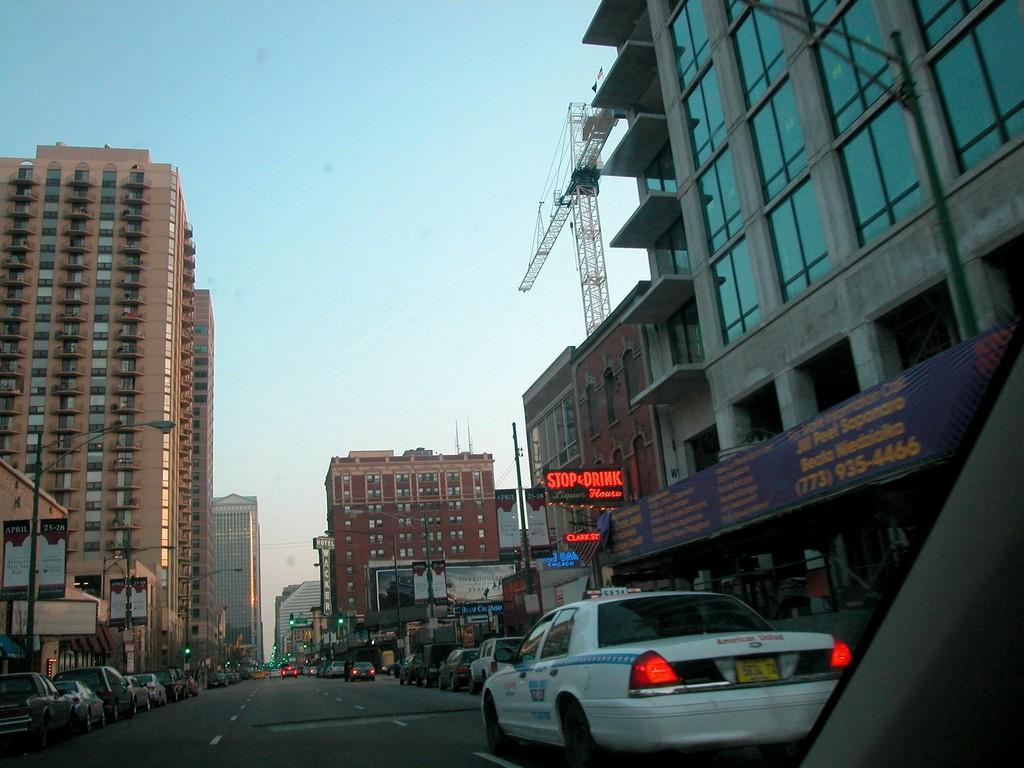<image>
Present a compact description of the photo's key features. A taxi driving near a Stop and Drink house restaurant. 